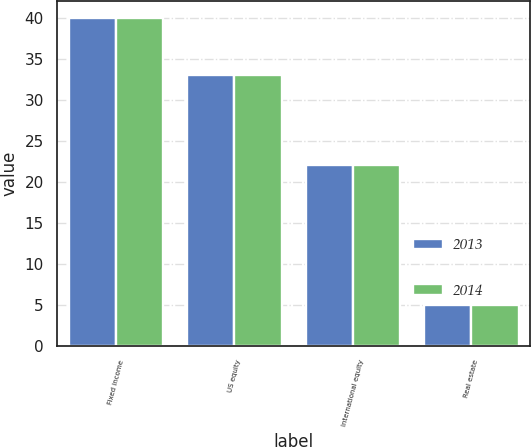Convert chart. <chart><loc_0><loc_0><loc_500><loc_500><stacked_bar_chart><ecel><fcel>Fixed income<fcel>US equity<fcel>International equity<fcel>Real estate<nl><fcel>2013<fcel>40<fcel>33<fcel>22<fcel>5<nl><fcel>2014<fcel>40<fcel>33<fcel>22<fcel>5<nl></chart> 